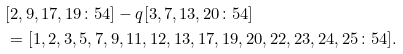Convert formula to latex. <formula><loc_0><loc_0><loc_500><loc_500>& [ 2 , 9 , 1 7 , 1 9 \colon 5 4 ] - q [ 3 , 7 , 1 3 , 2 0 \colon 5 4 ] \\ & = [ 1 , 2 , 3 , 5 , 7 , 9 , 1 1 , 1 2 , 1 3 , 1 7 , 1 9 , 2 0 , 2 2 , 2 3 , 2 4 , 2 5 \colon 5 4 ] .</formula> 